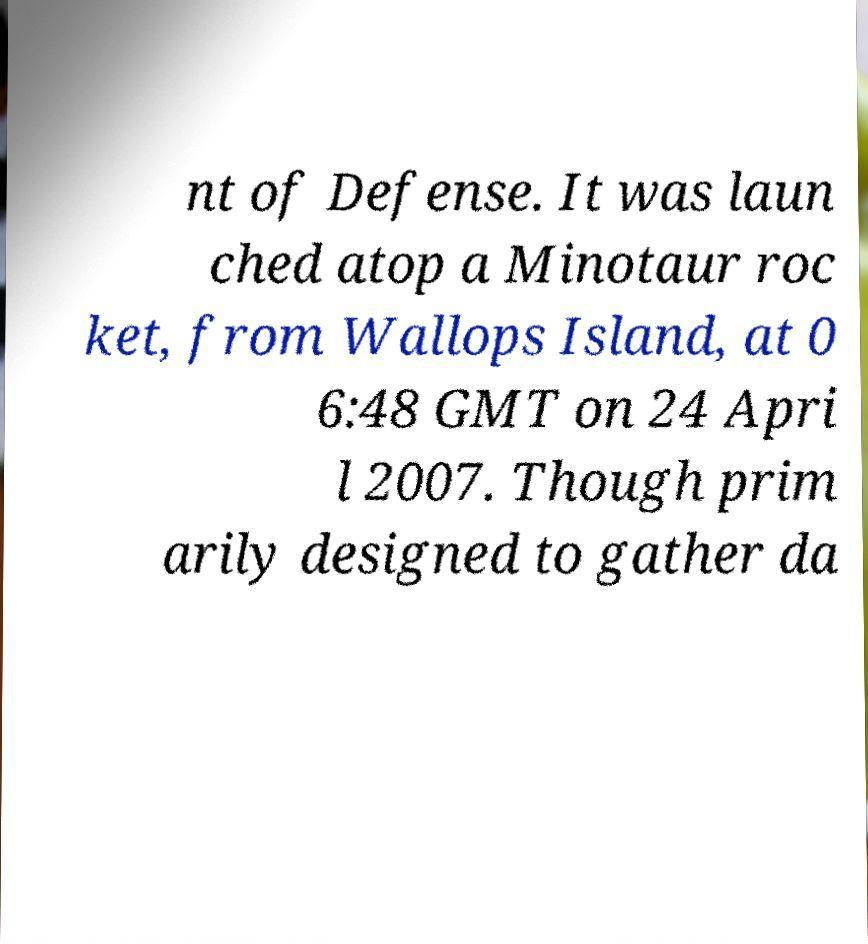Can you accurately transcribe the text from the provided image for me? nt of Defense. It was laun ched atop a Minotaur roc ket, from Wallops Island, at 0 6:48 GMT on 24 Apri l 2007. Though prim arily designed to gather da 